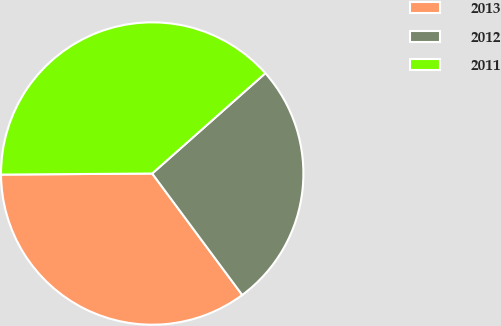Convert chart to OTSL. <chart><loc_0><loc_0><loc_500><loc_500><pie_chart><fcel>2013<fcel>2012<fcel>2011<nl><fcel>35.04%<fcel>26.39%<fcel>38.57%<nl></chart> 